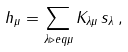Convert formula to latex. <formula><loc_0><loc_0><loc_500><loc_500>h _ { \mu } = \sum _ { \lambda \triangleright e q \mu } K _ { \lambda \mu } \, s _ { \lambda } \, ,</formula> 